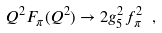Convert formula to latex. <formula><loc_0><loc_0><loc_500><loc_500>Q ^ { 2 } F _ { \pi } ( Q ^ { 2 } ) \to { 2 g ^ { 2 } _ { 5 } f _ { \pi } ^ { 2 } } \ ,</formula> 